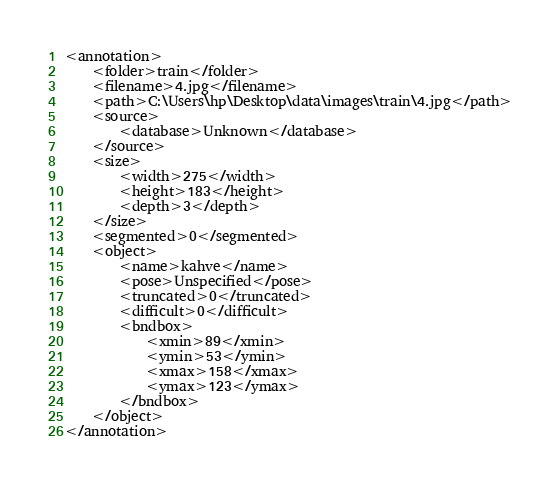<code> <loc_0><loc_0><loc_500><loc_500><_XML_><annotation>
	<folder>train</folder>
	<filename>4.jpg</filename>
	<path>C:\Users\hp\Desktop\data\images\train\4.jpg</path>
	<source>
		<database>Unknown</database>
	</source>
	<size>
		<width>275</width>
		<height>183</height>
		<depth>3</depth>
	</size>
	<segmented>0</segmented>
	<object>
		<name>kahve</name>
		<pose>Unspecified</pose>
		<truncated>0</truncated>
		<difficult>0</difficult>
		<bndbox>
			<xmin>89</xmin>
			<ymin>53</ymin>
			<xmax>158</xmax>
			<ymax>123</ymax>
		</bndbox>
	</object>
</annotation>
</code> 